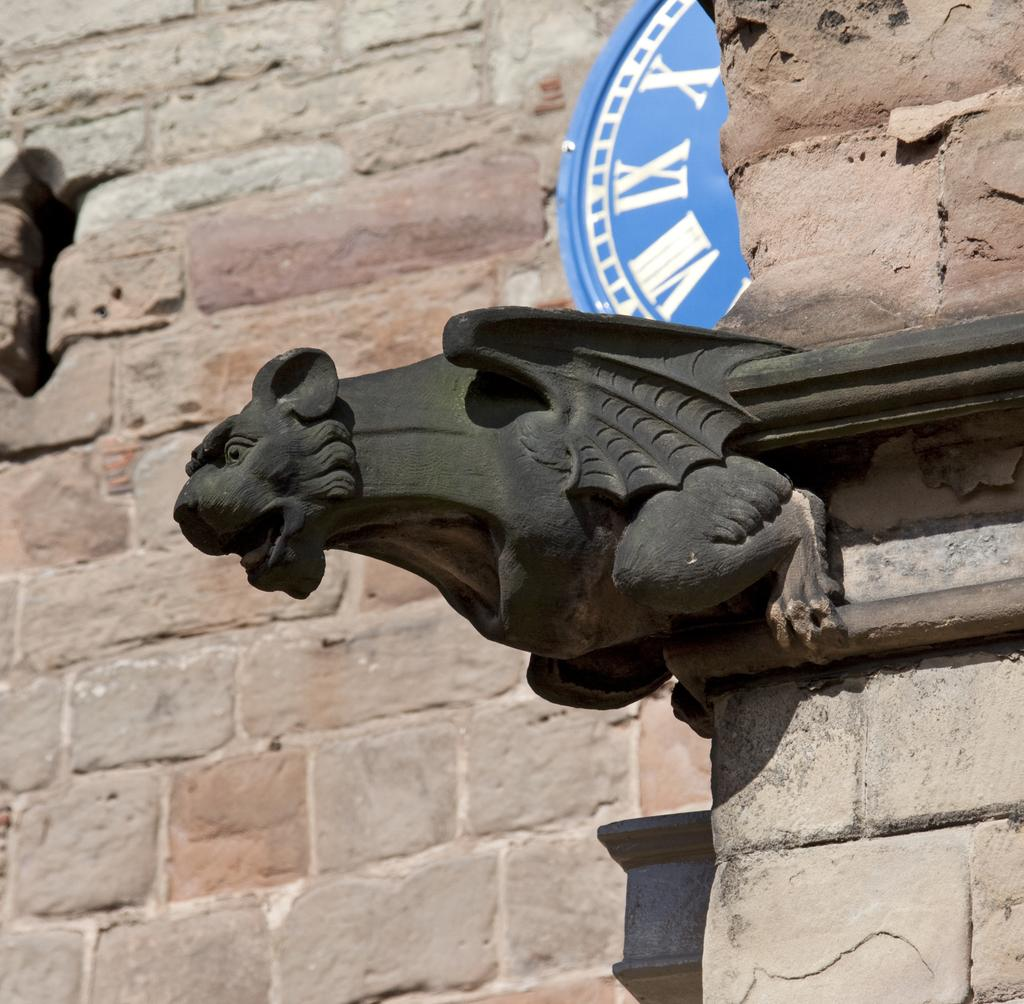What type of structure is depicted in the image? There is a historical wall in the image. What materials were used to construct the wall? The wall is made of stone and brick. What can be seen near the wall in the image? There is a black lion sculpture near the wall. What are the characteristics of the lion sculpture? The lion sculpture is black in color and has wings. What type of note is attached to the lion sculpture in the image? There is no note attached to the lion sculpture in the image. Can you see any ants crawling on the wall in the image? There is no mention of ants in the image, so we cannot determine if any are present. 